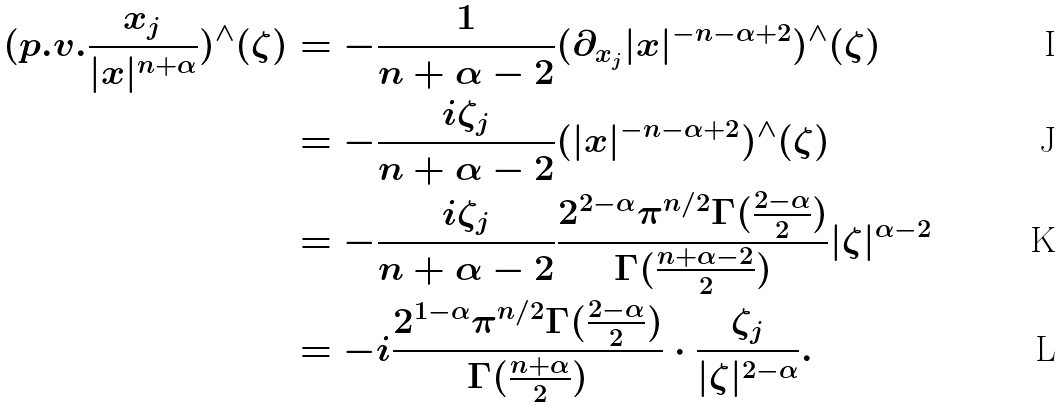<formula> <loc_0><loc_0><loc_500><loc_500>( p . v . \frac { x _ { j } } { | x | ^ { n + \alpha } } ) ^ { \wedge } ( \zeta ) & = - \frac { 1 } { n + \alpha - 2 } ( \partial _ { x _ { j } } | x | ^ { - n - \alpha + 2 } ) ^ { \wedge } ( \zeta ) \\ & = - \frac { i \zeta _ { j } } { n + \alpha - 2 } ( | x | ^ { - n - \alpha + 2 } ) ^ { \wedge } ( \zeta ) \\ & = - \frac { i \zeta _ { j } } { n + \alpha - 2 } \frac { 2 ^ { 2 - \alpha } \pi ^ { n / 2 } \Gamma ( \frac { 2 - \alpha } { 2 } ) } { \Gamma ( \frac { n + \alpha - 2 } { 2 } ) } | \zeta | ^ { \alpha - 2 } \\ & = - i \frac { 2 ^ { 1 - \alpha } \pi ^ { n / 2 } \Gamma ( \frac { 2 - \alpha } { 2 } ) } { \Gamma ( \frac { n + \alpha } { 2 } ) } \cdot \frac { \zeta _ { j } } { | \zeta | ^ { 2 - \alpha } } .</formula> 